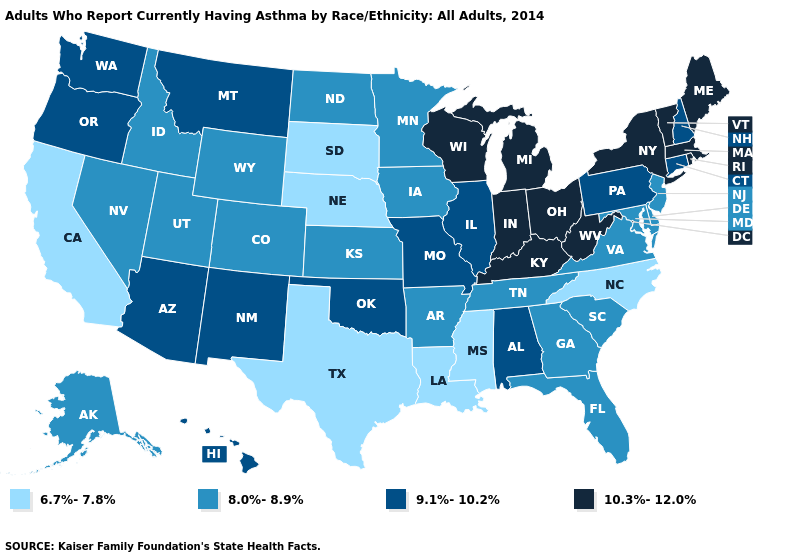Does the first symbol in the legend represent the smallest category?
Be succinct. Yes. What is the value of Utah?
Concise answer only. 8.0%-8.9%. What is the lowest value in states that border Vermont?
Short answer required. 9.1%-10.2%. What is the highest value in the West ?
Concise answer only. 9.1%-10.2%. Does South Carolina have the highest value in the South?
Short answer required. No. Which states have the lowest value in the USA?
Be succinct. California, Louisiana, Mississippi, Nebraska, North Carolina, South Dakota, Texas. Does Ohio have the highest value in the USA?
Quick response, please. Yes. Which states have the highest value in the USA?
Quick response, please. Indiana, Kentucky, Maine, Massachusetts, Michigan, New York, Ohio, Rhode Island, Vermont, West Virginia, Wisconsin. What is the highest value in the USA?
Be succinct. 10.3%-12.0%. How many symbols are there in the legend?
Keep it brief. 4. Does the first symbol in the legend represent the smallest category?
Short answer required. Yes. Name the states that have a value in the range 8.0%-8.9%?
Answer briefly. Alaska, Arkansas, Colorado, Delaware, Florida, Georgia, Idaho, Iowa, Kansas, Maryland, Minnesota, Nevada, New Jersey, North Dakota, South Carolina, Tennessee, Utah, Virginia, Wyoming. Name the states that have a value in the range 9.1%-10.2%?
Give a very brief answer. Alabama, Arizona, Connecticut, Hawaii, Illinois, Missouri, Montana, New Hampshire, New Mexico, Oklahoma, Oregon, Pennsylvania, Washington. Name the states that have a value in the range 10.3%-12.0%?
Give a very brief answer. Indiana, Kentucky, Maine, Massachusetts, Michigan, New York, Ohio, Rhode Island, Vermont, West Virginia, Wisconsin. What is the highest value in the West ?
Write a very short answer. 9.1%-10.2%. 